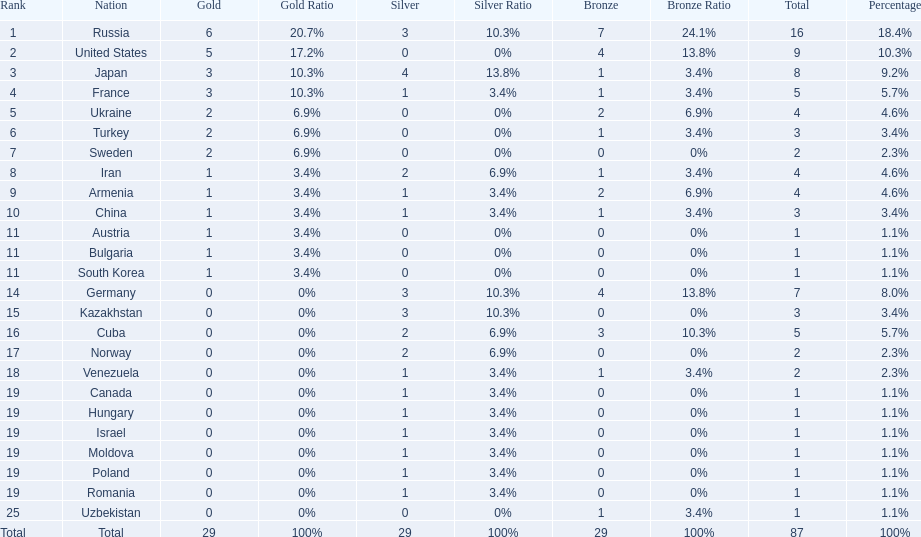What were the nations that participated in the 1995 world wrestling championships? Russia, United States, Japan, France, Ukraine, Turkey, Sweden, Iran, Armenia, China, Austria, Bulgaria, South Korea, Germany, Kazakhstan, Cuba, Norway, Venezuela, Canada, Hungary, Israel, Moldova, Poland, Romania, Uzbekistan. How many gold medals did the united states earn in the championship? 5. What amount of medals earner was greater than this value? 6. What country earned these medals? Russia. 